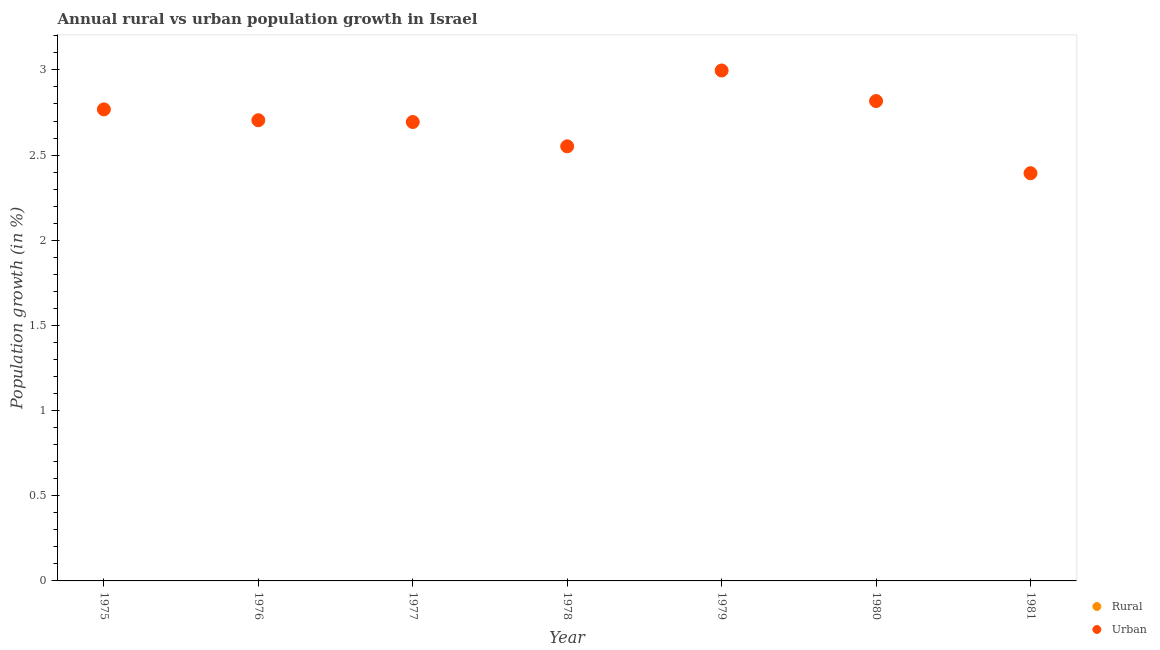How many different coloured dotlines are there?
Make the answer very short. 1. What is the urban population growth in 1977?
Provide a short and direct response. 2.69. Across all years, what is the maximum urban population growth?
Offer a very short reply. 3. What is the difference between the urban population growth in 1978 and that in 1980?
Provide a succinct answer. -0.27. What is the difference between the rural population growth in 1975 and the urban population growth in 1978?
Make the answer very short. -2.55. What is the average urban population growth per year?
Your response must be concise. 2.7. What is the ratio of the urban population growth in 1975 to that in 1978?
Your answer should be compact. 1.08. Is the urban population growth in 1977 less than that in 1981?
Offer a very short reply. No. What is the difference between the highest and the second highest urban population growth?
Provide a short and direct response. 0.18. What is the difference between the highest and the lowest urban population growth?
Provide a short and direct response. 0.6. In how many years, is the urban population growth greater than the average urban population growth taken over all years?
Provide a succinct answer. 4. Is the sum of the urban population growth in 1977 and 1980 greater than the maximum rural population growth across all years?
Offer a terse response. Yes. Is the rural population growth strictly greater than the urban population growth over the years?
Provide a succinct answer. No. How many years are there in the graph?
Offer a terse response. 7. Are the values on the major ticks of Y-axis written in scientific E-notation?
Make the answer very short. No. How many legend labels are there?
Offer a very short reply. 2. How are the legend labels stacked?
Keep it short and to the point. Vertical. What is the title of the graph?
Your answer should be very brief. Annual rural vs urban population growth in Israel. What is the label or title of the Y-axis?
Keep it short and to the point. Population growth (in %). What is the Population growth (in %) in Rural in 1975?
Offer a very short reply. 0. What is the Population growth (in %) in Urban  in 1975?
Provide a short and direct response. 2.77. What is the Population growth (in %) of Rural in 1976?
Give a very brief answer. 0. What is the Population growth (in %) in Urban  in 1976?
Ensure brevity in your answer.  2.7. What is the Population growth (in %) in Rural in 1977?
Ensure brevity in your answer.  0. What is the Population growth (in %) in Urban  in 1977?
Provide a succinct answer. 2.69. What is the Population growth (in %) in Rural in 1978?
Offer a very short reply. 0. What is the Population growth (in %) of Urban  in 1978?
Your response must be concise. 2.55. What is the Population growth (in %) of Rural in 1979?
Your answer should be compact. 0. What is the Population growth (in %) in Urban  in 1979?
Your answer should be very brief. 3. What is the Population growth (in %) in Urban  in 1980?
Keep it short and to the point. 2.82. What is the Population growth (in %) in Urban  in 1981?
Your response must be concise. 2.39. Across all years, what is the maximum Population growth (in %) in Urban ?
Offer a very short reply. 3. Across all years, what is the minimum Population growth (in %) in Urban ?
Offer a very short reply. 2.39. What is the total Population growth (in %) of Rural in the graph?
Offer a terse response. 0. What is the total Population growth (in %) in Urban  in the graph?
Provide a short and direct response. 18.93. What is the difference between the Population growth (in %) in Urban  in 1975 and that in 1976?
Ensure brevity in your answer.  0.06. What is the difference between the Population growth (in %) in Urban  in 1975 and that in 1977?
Keep it short and to the point. 0.07. What is the difference between the Population growth (in %) in Urban  in 1975 and that in 1978?
Your answer should be compact. 0.22. What is the difference between the Population growth (in %) in Urban  in 1975 and that in 1979?
Provide a short and direct response. -0.23. What is the difference between the Population growth (in %) of Urban  in 1975 and that in 1980?
Offer a very short reply. -0.05. What is the difference between the Population growth (in %) in Urban  in 1975 and that in 1981?
Your response must be concise. 0.37. What is the difference between the Population growth (in %) in Urban  in 1976 and that in 1977?
Offer a very short reply. 0.01. What is the difference between the Population growth (in %) of Urban  in 1976 and that in 1978?
Ensure brevity in your answer.  0.15. What is the difference between the Population growth (in %) in Urban  in 1976 and that in 1979?
Provide a succinct answer. -0.29. What is the difference between the Population growth (in %) of Urban  in 1976 and that in 1980?
Keep it short and to the point. -0.11. What is the difference between the Population growth (in %) in Urban  in 1976 and that in 1981?
Your answer should be very brief. 0.31. What is the difference between the Population growth (in %) in Urban  in 1977 and that in 1978?
Provide a succinct answer. 0.14. What is the difference between the Population growth (in %) in Urban  in 1977 and that in 1979?
Offer a very short reply. -0.3. What is the difference between the Population growth (in %) in Urban  in 1977 and that in 1980?
Provide a short and direct response. -0.12. What is the difference between the Population growth (in %) of Urban  in 1977 and that in 1981?
Provide a short and direct response. 0.3. What is the difference between the Population growth (in %) in Urban  in 1978 and that in 1979?
Offer a very short reply. -0.45. What is the difference between the Population growth (in %) of Urban  in 1978 and that in 1980?
Your answer should be very brief. -0.27. What is the difference between the Population growth (in %) of Urban  in 1978 and that in 1981?
Provide a short and direct response. 0.16. What is the difference between the Population growth (in %) in Urban  in 1979 and that in 1980?
Ensure brevity in your answer.  0.18. What is the difference between the Population growth (in %) of Urban  in 1979 and that in 1981?
Make the answer very short. 0.6. What is the difference between the Population growth (in %) in Urban  in 1980 and that in 1981?
Give a very brief answer. 0.42. What is the average Population growth (in %) in Rural per year?
Your answer should be compact. 0. What is the average Population growth (in %) in Urban  per year?
Provide a short and direct response. 2.7. What is the ratio of the Population growth (in %) in Urban  in 1975 to that in 1976?
Make the answer very short. 1.02. What is the ratio of the Population growth (in %) of Urban  in 1975 to that in 1977?
Your answer should be compact. 1.03. What is the ratio of the Population growth (in %) in Urban  in 1975 to that in 1978?
Provide a succinct answer. 1.08. What is the ratio of the Population growth (in %) in Urban  in 1975 to that in 1979?
Ensure brevity in your answer.  0.92. What is the ratio of the Population growth (in %) of Urban  in 1975 to that in 1980?
Your answer should be compact. 0.98. What is the ratio of the Population growth (in %) in Urban  in 1975 to that in 1981?
Give a very brief answer. 1.16. What is the ratio of the Population growth (in %) in Urban  in 1976 to that in 1978?
Provide a short and direct response. 1.06. What is the ratio of the Population growth (in %) of Urban  in 1976 to that in 1979?
Your answer should be compact. 0.9. What is the ratio of the Population growth (in %) of Urban  in 1976 to that in 1980?
Give a very brief answer. 0.96. What is the ratio of the Population growth (in %) of Urban  in 1976 to that in 1981?
Provide a short and direct response. 1.13. What is the ratio of the Population growth (in %) in Urban  in 1977 to that in 1978?
Offer a very short reply. 1.06. What is the ratio of the Population growth (in %) in Urban  in 1977 to that in 1979?
Provide a short and direct response. 0.9. What is the ratio of the Population growth (in %) in Urban  in 1977 to that in 1980?
Provide a short and direct response. 0.96. What is the ratio of the Population growth (in %) of Urban  in 1977 to that in 1981?
Give a very brief answer. 1.13. What is the ratio of the Population growth (in %) in Urban  in 1978 to that in 1979?
Give a very brief answer. 0.85. What is the ratio of the Population growth (in %) of Urban  in 1978 to that in 1980?
Offer a terse response. 0.91. What is the ratio of the Population growth (in %) of Urban  in 1978 to that in 1981?
Your answer should be very brief. 1.07. What is the ratio of the Population growth (in %) of Urban  in 1979 to that in 1980?
Make the answer very short. 1.06. What is the ratio of the Population growth (in %) in Urban  in 1979 to that in 1981?
Give a very brief answer. 1.25. What is the ratio of the Population growth (in %) in Urban  in 1980 to that in 1981?
Ensure brevity in your answer.  1.18. What is the difference between the highest and the second highest Population growth (in %) of Urban ?
Give a very brief answer. 0.18. What is the difference between the highest and the lowest Population growth (in %) in Urban ?
Keep it short and to the point. 0.6. 